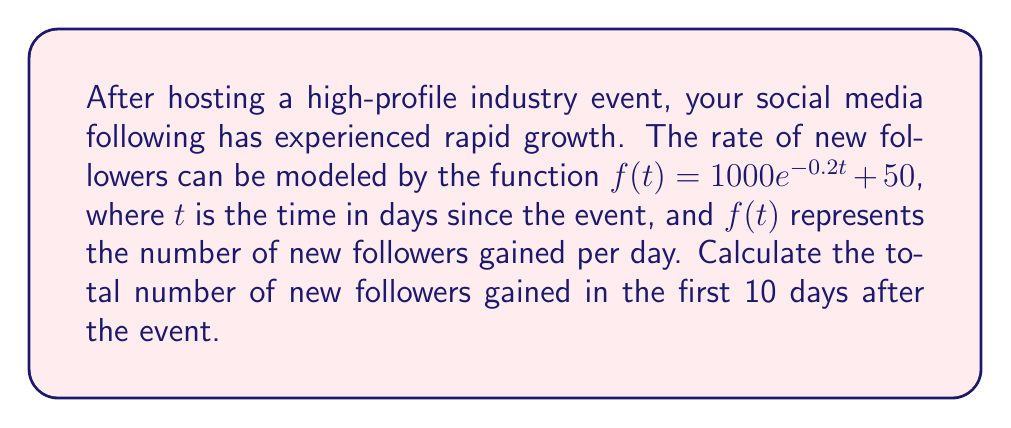What is the answer to this math problem? To solve this problem, we need to find the definite integral of the given function over the interval [0, 10]. This will give us the total area under the curve, which represents the total number of new followers gained over the 10-day period.

The function is $f(t) = 1000e^{-0.2t} + 50$

Step 1: Set up the definite integral
$$\int_0^{10} (1000e^{-0.2t} + 50) dt$$

Step 2: Integrate the function
For the exponential part:
$$\int 1000e^{-0.2t} dt = -5000e^{-0.2t} + C$$

For the constant part:
$$\int 50 dt = 50t + C$$

Combining these:
$$\int (1000e^{-0.2t} + 50) dt = -5000e^{-0.2t} + 50t + C$$

Step 3: Apply the limits of integration
$$[-5000e^{-0.2t} + 50t]_0^{10}$$

Step 4: Evaluate
At t = 10: $-5000e^{-2} + 500$
At t = 0: $-5000 + 0$

Step 5: Subtract
$(-5000e^{-2} + 500) - (-5000) = -5000e^{-2} + 5500$

Step 6: Calculate the final value
$-5000 * 0.1353 + 5500 = 4823.5$

Therefore, the total number of new followers gained in the first 10 days after the event is approximately 4,824.
Answer: 4,824 new followers 